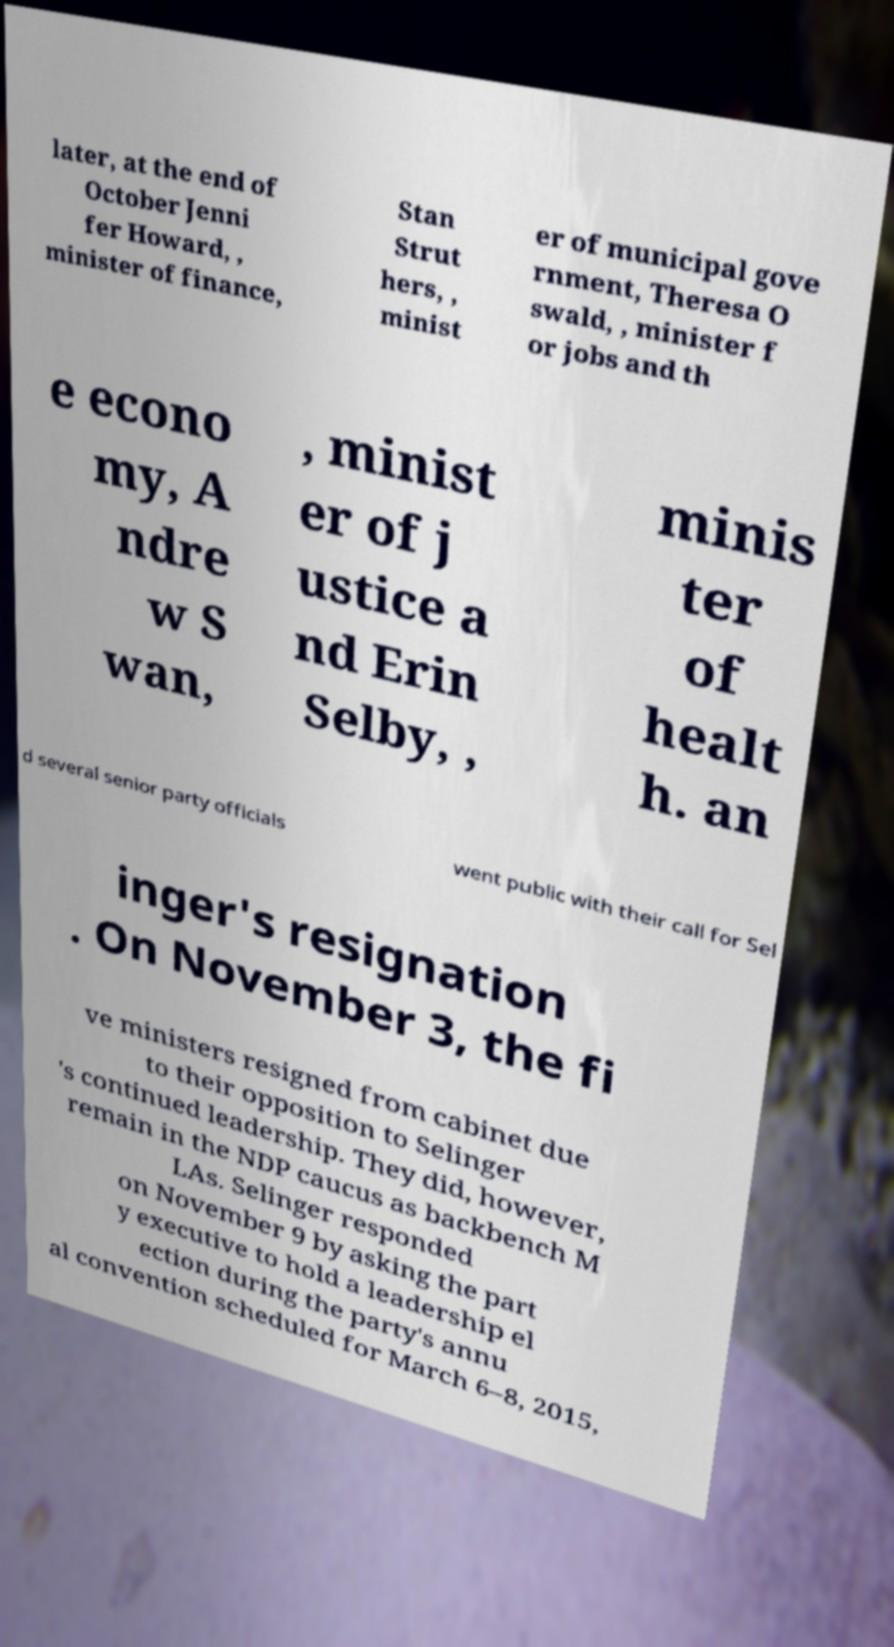Could you extract and type out the text from this image? later, at the end of October Jenni fer Howard, , minister of finance, Stan Strut hers, , minist er of municipal gove rnment, Theresa O swald, , minister f or jobs and th e econo my, A ndre w S wan, , minist er of j ustice a nd Erin Selby, , minis ter of healt h. an d several senior party officials went public with their call for Sel inger's resignation . On November 3, the fi ve ministers resigned from cabinet due to their opposition to Selinger 's continued leadership. They did, however, remain in the NDP caucus as backbench M LAs. Selinger responded on November 9 by asking the part y executive to hold a leadership el ection during the party's annu al convention scheduled for March 6–8, 2015, 